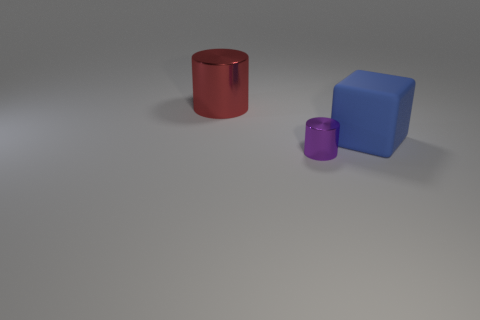Is there any other thing that is made of the same material as the blue object?
Keep it short and to the point. No. What number of other objects are the same shape as the blue rubber object?
Give a very brief answer. 0. The object that is both on the right side of the big metallic cylinder and left of the blue object has what shape?
Offer a very short reply. Cylinder. Are there any large red things on the left side of the matte block?
Keep it short and to the point. Yes. There is another red shiny object that is the same shape as the small object; what is its size?
Your answer should be compact. Large. Is there any other thing that has the same size as the purple object?
Make the answer very short. No. Is the shape of the big red metal object the same as the small purple metallic object?
Keep it short and to the point. Yes. There is a metallic cylinder behind the tiny purple metal cylinder left of the rubber cube; how big is it?
Your answer should be very brief. Large. What color is the other metallic thing that is the same shape as the small purple object?
Give a very brief answer. Red. The block has what size?
Offer a terse response. Large. 